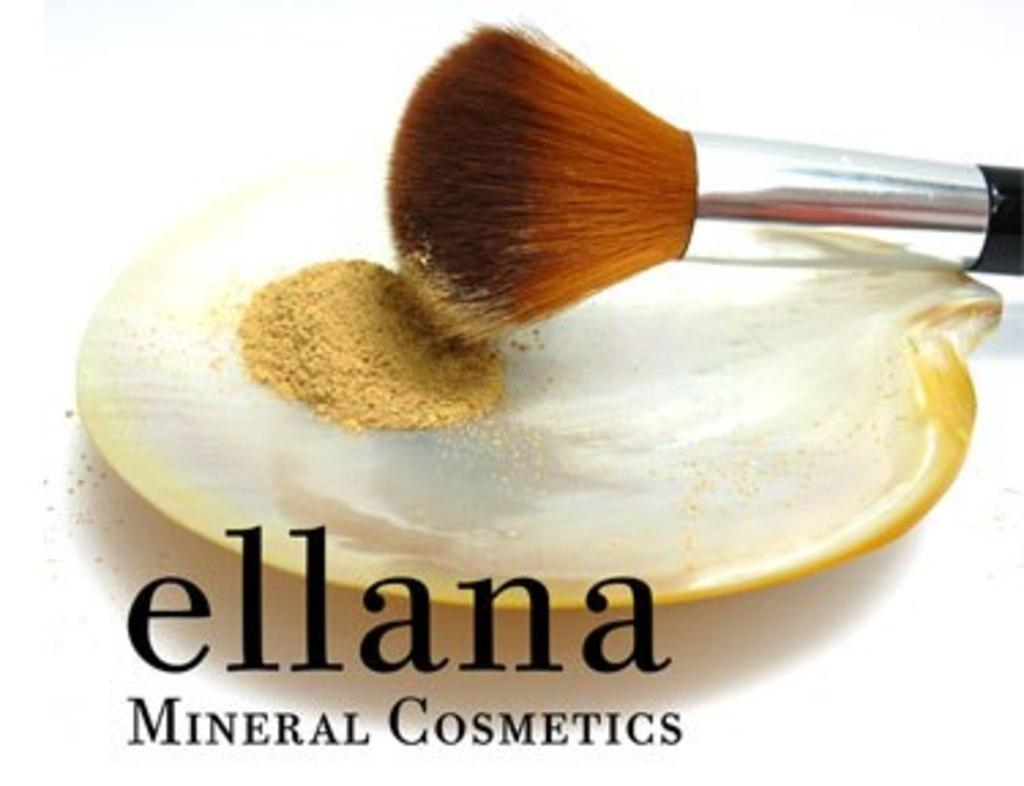<image>
Give a short and clear explanation of the subsequent image. An advertisement for Ellana Mineral Cosmetics shows a brush. 